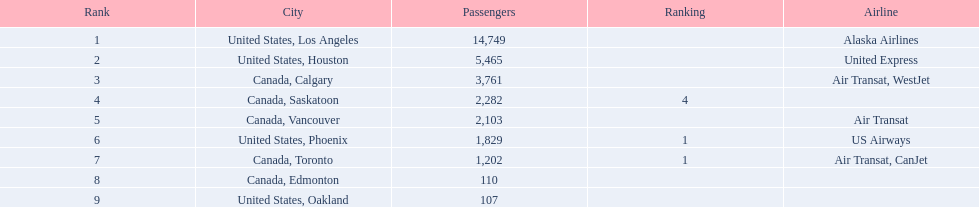Which cities had less than 2,000 passengers? United States, Phoenix, Canada, Toronto, Canada, Edmonton, United States, Oakland. Of these cities, which had fewer than 1,000 passengers? Canada, Edmonton, United States, Oakland. Of the cities in the previous answer, which one had only 107 passengers? United States, Oakland. 